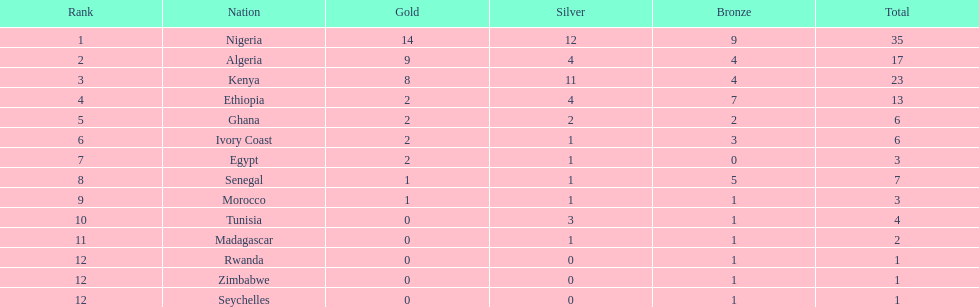Which nation secured the highest number of medals? Nigeria. 